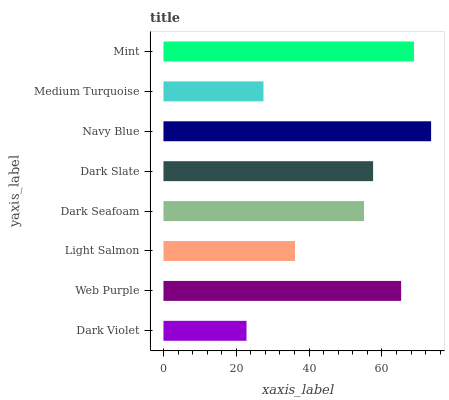Is Dark Violet the minimum?
Answer yes or no. Yes. Is Navy Blue the maximum?
Answer yes or no. Yes. Is Web Purple the minimum?
Answer yes or no. No. Is Web Purple the maximum?
Answer yes or no. No. Is Web Purple greater than Dark Violet?
Answer yes or no. Yes. Is Dark Violet less than Web Purple?
Answer yes or no. Yes. Is Dark Violet greater than Web Purple?
Answer yes or no. No. Is Web Purple less than Dark Violet?
Answer yes or no. No. Is Dark Slate the high median?
Answer yes or no. Yes. Is Dark Seafoam the low median?
Answer yes or no. Yes. Is Navy Blue the high median?
Answer yes or no. No. Is Navy Blue the low median?
Answer yes or no. No. 